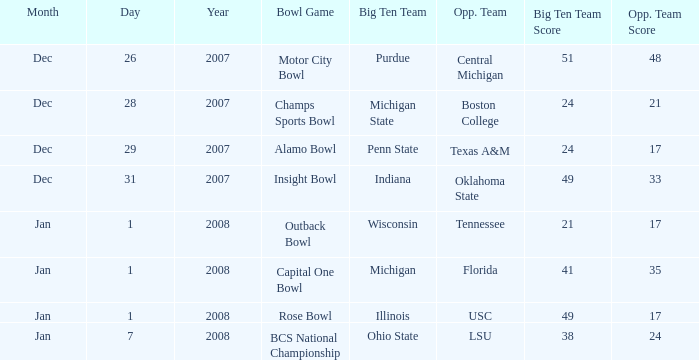Who was Purdue's opponent? Central Michigan. 